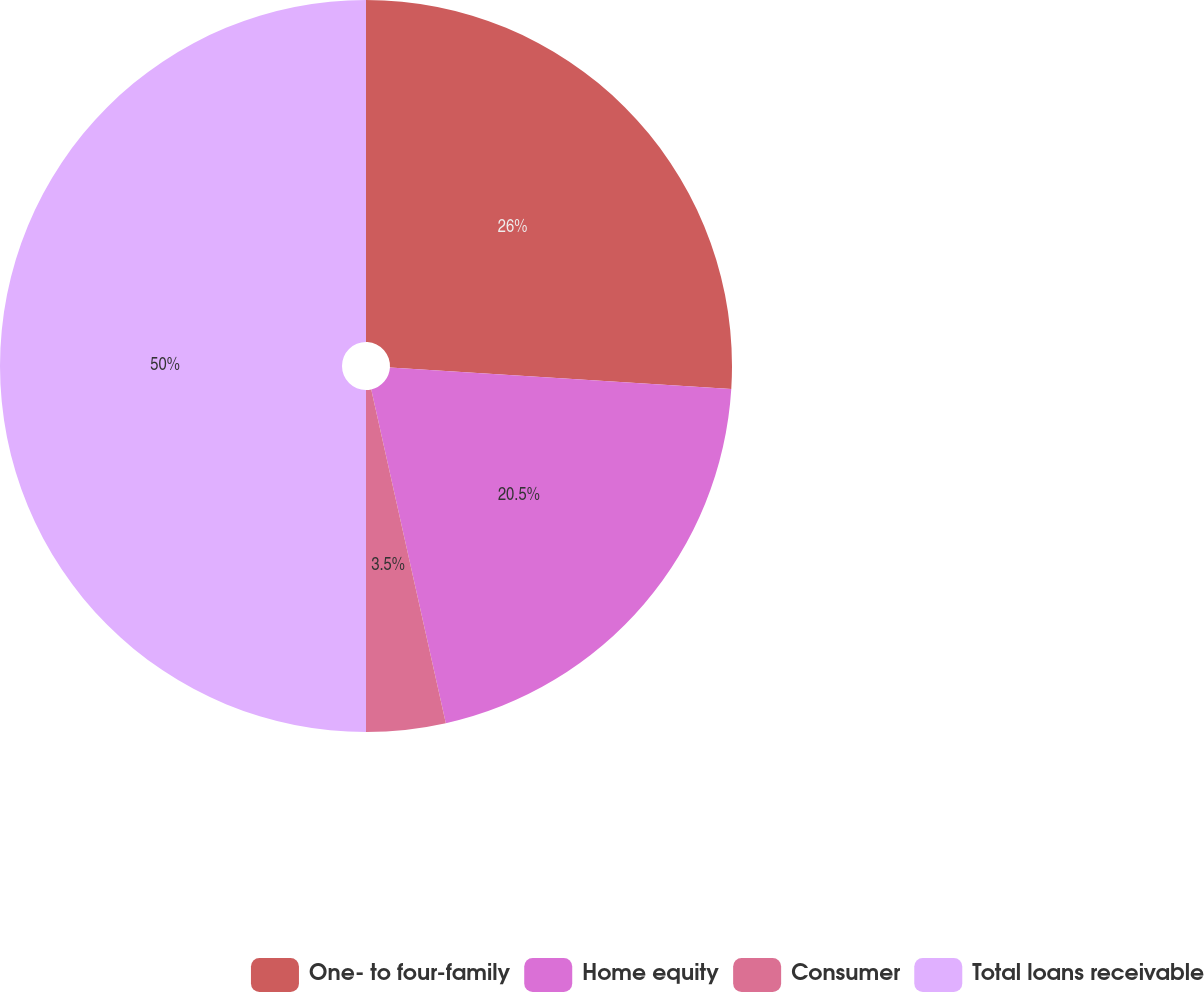<chart> <loc_0><loc_0><loc_500><loc_500><pie_chart><fcel>One- to four-family<fcel>Home equity<fcel>Consumer<fcel>Total loans receivable<nl><fcel>26.0%<fcel>20.5%<fcel>3.5%<fcel>50.0%<nl></chart> 